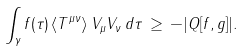<formula> <loc_0><loc_0><loc_500><loc_500>\int _ { \gamma } f ( \tau ) \, \langle T ^ { \mu \nu } \rangle \, V _ { \mu } V _ { \nu } \, d \tau \, \geq \, - | Q [ f , g ] | .</formula> 